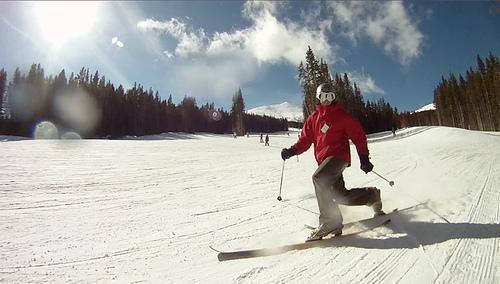What is causing the glare in the image?
Indicate the correct response and explain using: 'Answer: answer
Rationale: rationale.'
Options: Flashlights, street lights, sun, torches. Answer: sun.
Rationale: The image was taken with the camera facing the sun which caused a glare. 